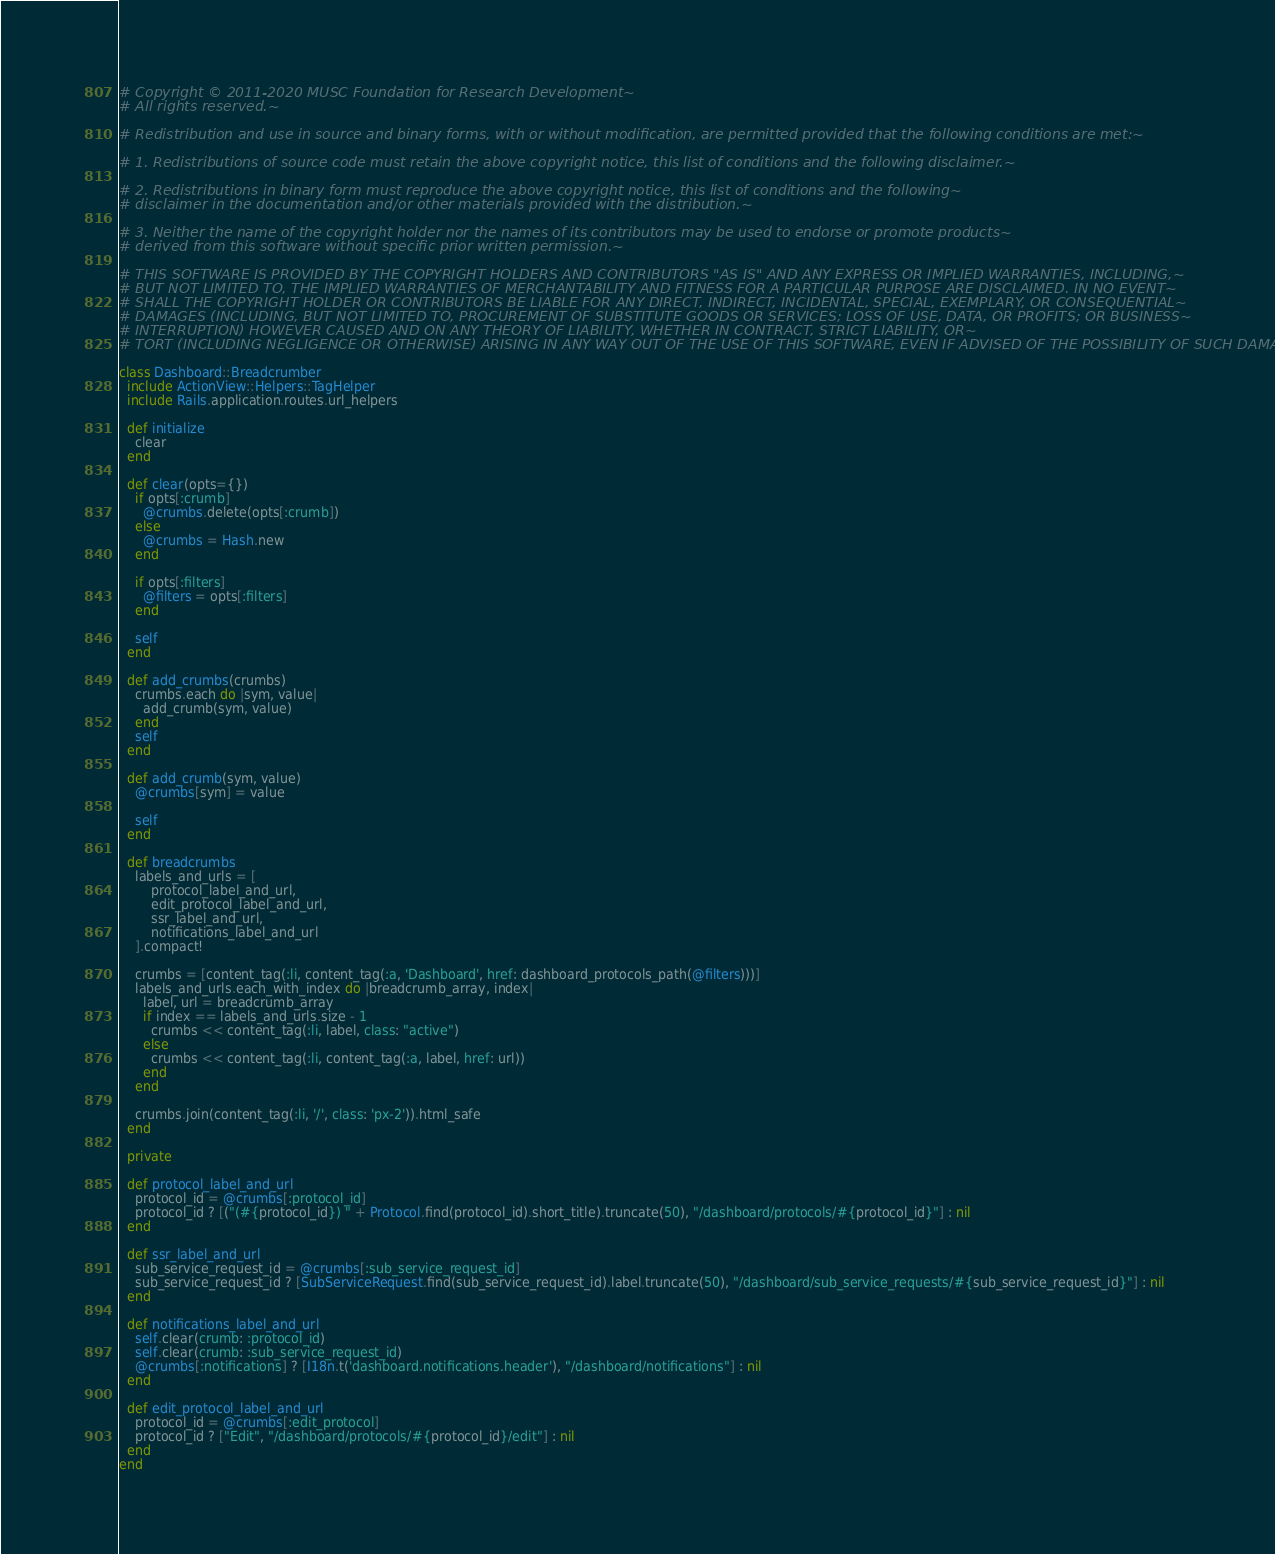<code> <loc_0><loc_0><loc_500><loc_500><_Ruby_># Copyright © 2011-2020 MUSC Foundation for Research Development~
# All rights reserved.~

# Redistribution and use in source and binary forms, with or without modification, are permitted provided that the following conditions are met:~

# 1. Redistributions of source code must retain the above copyright notice, this list of conditions and the following disclaimer.~

# 2. Redistributions in binary form must reproduce the above copyright notice, this list of conditions and the following~
# disclaimer in the documentation and/or other materials provided with the distribution.~

# 3. Neither the name of the copyright holder nor the names of its contributors may be used to endorse or promote products~
# derived from this software without specific prior written permission.~

# THIS SOFTWARE IS PROVIDED BY THE COPYRIGHT HOLDERS AND CONTRIBUTORS "AS IS" AND ANY EXPRESS OR IMPLIED WARRANTIES, INCLUDING,~
# BUT NOT LIMITED TO, THE IMPLIED WARRANTIES OF MERCHANTABILITY AND FITNESS FOR A PARTICULAR PURPOSE ARE DISCLAIMED. IN NO EVENT~
# SHALL THE COPYRIGHT HOLDER OR CONTRIBUTORS BE LIABLE FOR ANY DIRECT, INDIRECT, INCIDENTAL, SPECIAL, EXEMPLARY, OR CONSEQUENTIAL~
# DAMAGES (INCLUDING, BUT NOT LIMITED TO, PROCUREMENT OF SUBSTITUTE GOODS OR SERVICES; LOSS OF USE, DATA, OR PROFITS; OR BUSINESS~
# INTERRUPTION) HOWEVER CAUSED AND ON ANY THEORY OF LIABILITY, WHETHER IN CONTRACT, STRICT LIABILITY, OR~
# TORT (INCLUDING NEGLIGENCE OR OTHERWISE) ARISING IN ANY WAY OUT OF THE USE OF THIS SOFTWARE, EVEN IF ADVISED OF THE POSSIBILITY OF SUCH DAMAGE.~

class Dashboard::Breadcrumber
  include ActionView::Helpers::TagHelper
  include Rails.application.routes.url_helpers

  def initialize
    clear
  end

  def clear(opts={})
    if opts[:crumb]
      @crumbs.delete(opts[:crumb])
    else
      @crumbs = Hash.new
    end

    if opts[:filters]
      @filters = opts[:filters]
    end

    self
  end

  def add_crumbs(crumbs)
    crumbs.each do |sym, value|
      add_crumb(sym, value)
    end
    self
  end

  def add_crumb(sym, value)
    @crumbs[sym] = value

    self
  end

  def breadcrumbs
    labels_and_urls = [
        protocol_label_and_url,
        edit_protocol_label_and_url,
        ssr_label_and_url,
        notifications_label_and_url
    ].compact!

    crumbs = [content_tag(:li, content_tag(:a, 'Dashboard', href: dashboard_protocols_path(@filters)))]
    labels_and_urls.each_with_index do |breadcrumb_array, index|
      label, url = breadcrumb_array
      if index == labels_and_urls.size - 1
        crumbs << content_tag(:li, label, class: "active")
      else
        crumbs << content_tag(:li, content_tag(:a, label, href: url))
      end
    end

    crumbs.join(content_tag(:li, '/', class: 'px-2')).html_safe
  end

  private

  def protocol_label_and_url
    protocol_id = @crumbs[:protocol_id]
    protocol_id ? [("(#{protocol_id}) " + Protocol.find(protocol_id).short_title).truncate(50), "/dashboard/protocols/#{protocol_id}"] : nil
  end

  def ssr_label_and_url
    sub_service_request_id = @crumbs[:sub_service_request_id]
    sub_service_request_id ? [SubServiceRequest.find(sub_service_request_id).label.truncate(50), "/dashboard/sub_service_requests/#{sub_service_request_id}"] : nil
  end

  def notifications_label_and_url
    self.clear(crumb: :protocol_id)
    self.clear(crumb: :sub_service_request_id)
    @crumbs[:notifications] ? [I18n.t('dashboard.notifications.header'), "/dashboard/notifications"] : nil
  end

  def edit_protocol_label_and_url
    protocol_id = @crumbs[:edit_protocol]
    protocol_id ? ["Edit", "/dashboard/protocols/#{protocol_id}/edit"] : nil
  end
end
</code> 